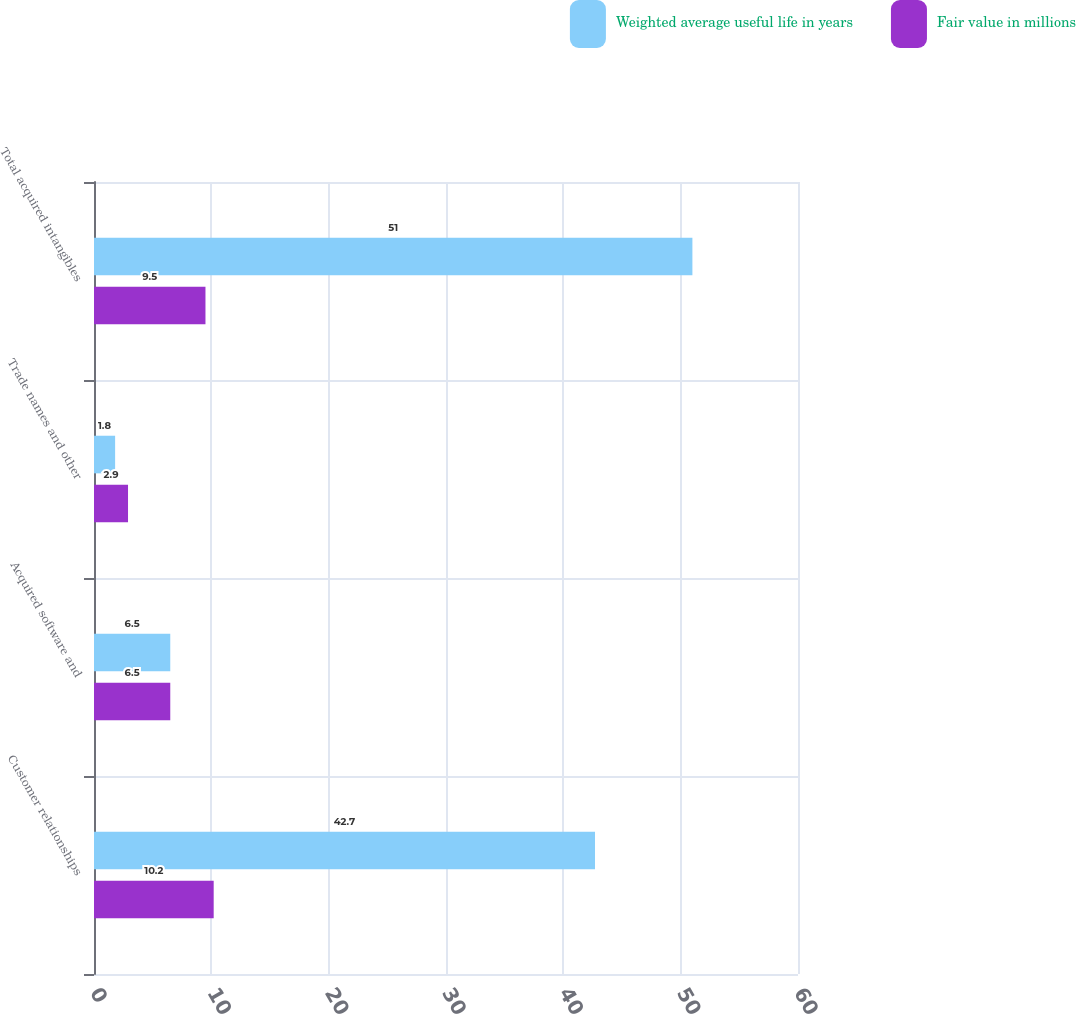Convert chart. <chart><loc_0><loc_0><loc_500><loc_500><stacked_bar_chart><ecel><fcel>Customer relationships<fcel>Acquired software and<fcel>Trade names and other<fcel>Total acquired intangibles<nl><fcel>Weighted average useful life in years<fcel>42.7<fcel>6.5<fcel>1.8<fcel>51<nl><fcel>Fair value in millions<fcel>10.2<fcel>6.5<fcel>2.9<fcel>9.5<nl></chart> 